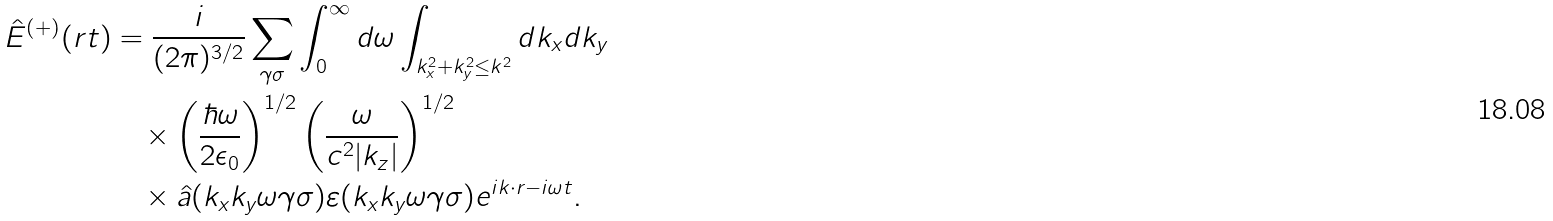<formula> <loc_0><loc_0><loc_500><loc_500>\hat { E } ^ { ( + ) } ( r t ) & = \frac { i } { ( 2 \pi ) ^ { 3 / 2 } } \sum _ { \gamma \sigma } \int _ { 0 } ^ { \infty } d \omega \int _ { k _ { x } ^ { 2 } + k _ { y } ^ { 2 } \leq k ^ { 2 } } d k _ { x } d k _ { y } \\ & \quad \times \left ( \frac { \hbar { \omega } } { 2 \epsilon _ { 0 } } \right ) ^ { 1 / 2 } \left ( \frac { \omega } { c ^ { 2 } | k _ { z } | } \right ) ^ { 1 / 2 } \\ & \quad \times \hat { a } ( k _ { x } k _ { y } \omega \gamma \sigma ) \varepsilon ( k _ { x } k _ { y } \omega \gamma \sigma ) e ^ { i k \cdot r - i \omega t } .</formula> 